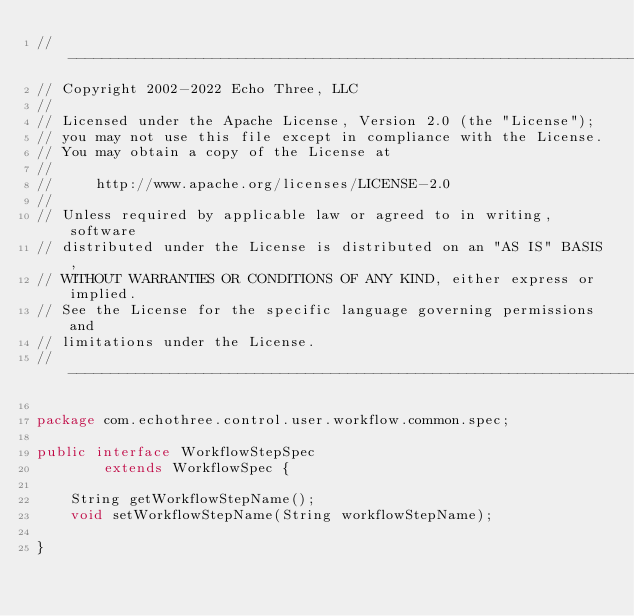<code> <loc_0><loc_0><loc_500><loc_500><_Java_>// --------------------------------------------------------------------------------
// Copyright 2002-2022 Echo Three, LLC
//
// Licensed under the Apache License, Version 2.0 (the "License");
// you may not use this file except in compliance with the License.
// You may obtain a copy of the License at
//
//     http://www.apache.org/licenses/LICENSE-2.0
//
// Unless required by applicable law or agreed to in writing, software
// distributed under the License is distributed on an "AS IS" BASIS,
// WITHOUT WARRANTIES OR CONDITIONS OF ANY KIND, either express or implied.
// See the License for the specific language governing permissions and
// limitations under the License.
// --------------------------------------------------------------------------------

package com.echothree.control.user.workflow.common.spec;

public interface WorkflowStepSpec
        extends WorkflowSpec {
    
    String getWorkflowStepName();
    void setWorkflowStepName(String workflowStepName);
    
}
</code> 